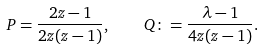Convert formula to latex. <formula><loc_0><loc_0><loc_500><loc_500>P = \frac { 2 z - 1 } { 2 z ( z - 1 ) } , \quad Q \colon = \frac { \lambda - 1 } { 4 z ( z - 1 ) } .</formula> 